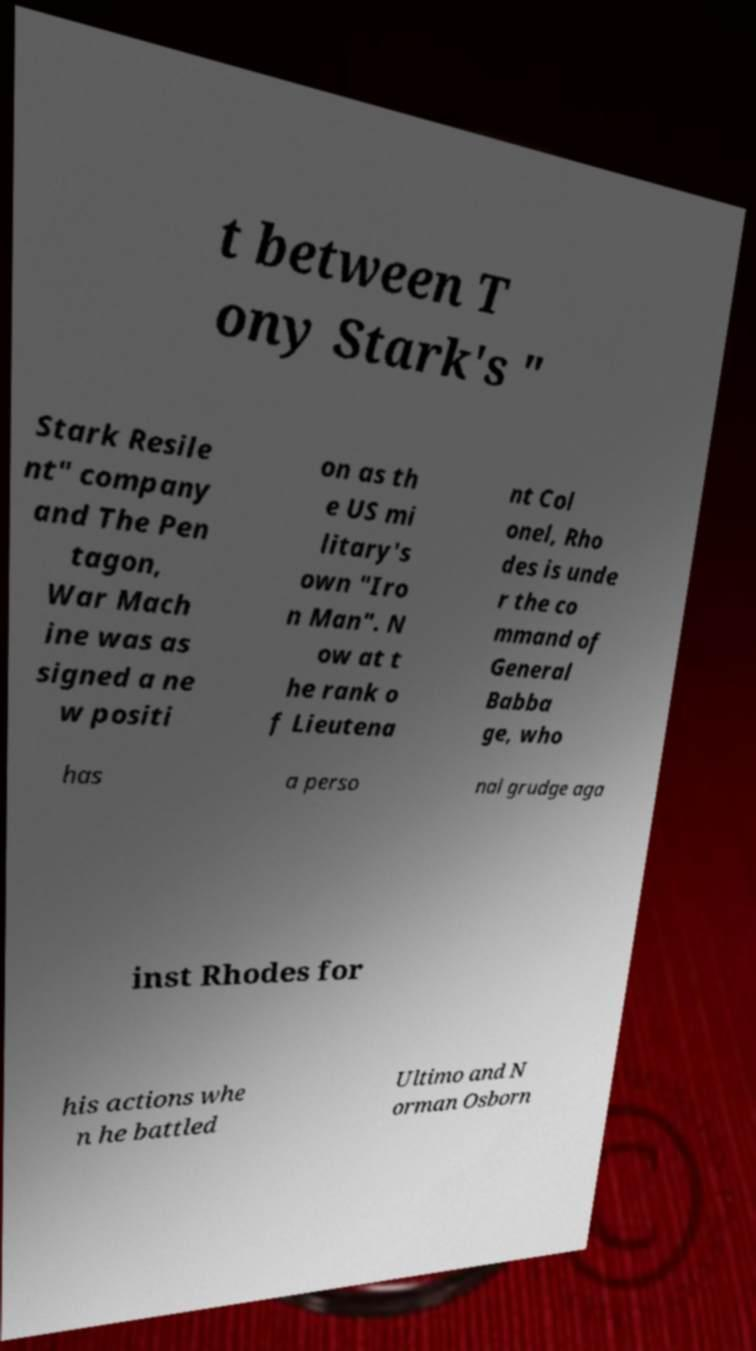Can you read and provide the text displayed in the image?This photo seems to have some interesting text. Can you extract and type it out for me? t between T ony Stark's " Stark Resile nt" company and The Pen tagon, War Mach ine was as signed a ne w positi on as th e US mi litary's own "Iro n Man". N ow at t he rank o f Lieutena nt Col onel, Rho des is unde r the co mmand of General Babba ge, who has a perso nal grudge aga inst Rhodes for his actions whe n he battled Ultimo and N orman Osborn 